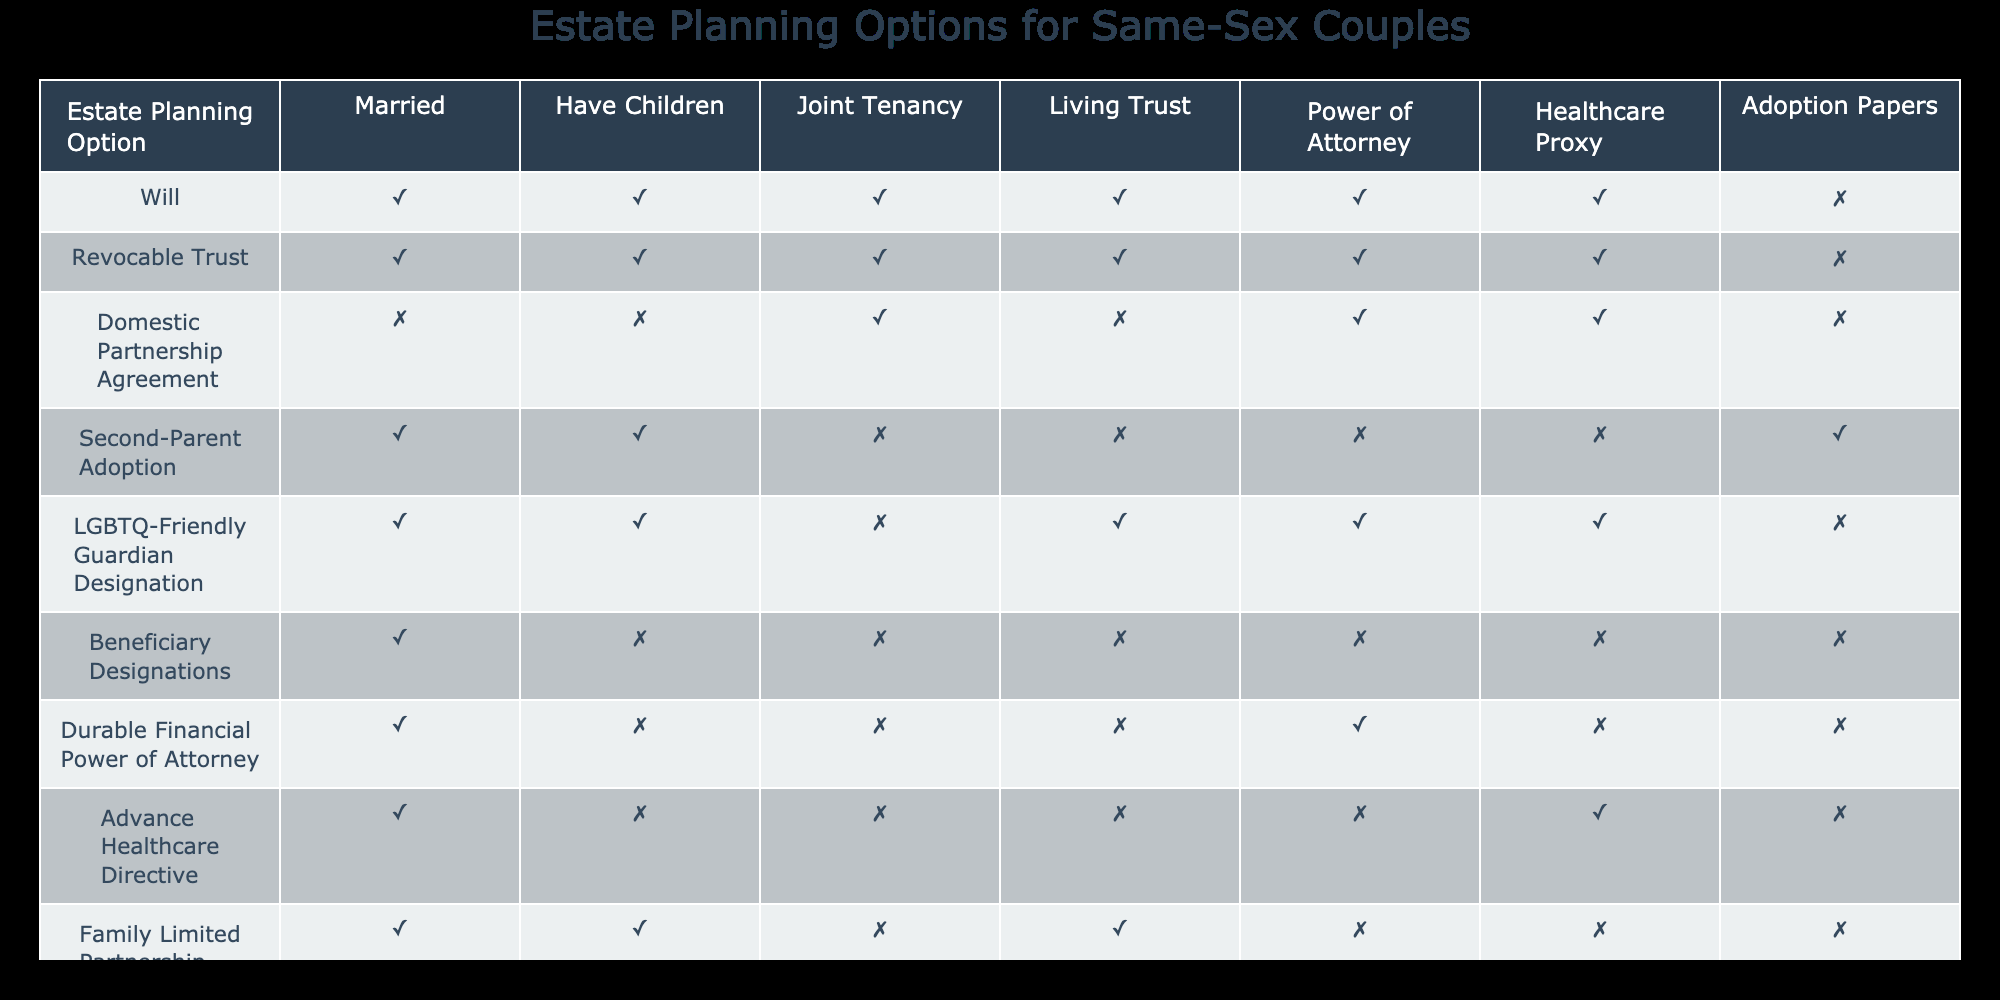What estate planning options are available for married same-sex couples with children? According to the table, married same-sex couples with children can use the following estate planning options: Will, Revocable Trust, Second-Parent Adoption, LGBTQ-Friendly Guardian Designation, Family Limited Partnership, and Qualified Terminable Interest Property Trust.
Answer: Will, Revocable Trust, Second-Parent Adoption, LGBTQ-Friendly Guardian Designation, Family Limited Partnership, Qualified Terminable Interest Property Trust Is a Domestic Partnership Agreement suitable for same-sex couples who have children? The table indicates that a Domestic Partnership Agreement is marked as applicable for couples without children (FALSE). Therefore, it is not suitable for same-sex couples who have children.
Answer: No How many estate planning options are available for same-sex couples without children? By looking at the table, the applicable options for same-sex couples without children are: Domestic Partnership Agreement, Beneficiary Designations, Durable Financial Power of Attorney, and Advance Healthcare Directive. This gives us a total of four options.
Answer: 4 Can same-sex couples benefit from Adoption Papers when they have children? The table shows that Adoption Papers are only applicable for same-sex couples who are married with children (TRUE). Thus, there is a benefit, but not for all couples with children.
Answer: Yes For LGBTQ-friendly Guardian Designation, is it available to married same-sex couples without children? The table specifies that LGBTQ-friendly Guardian Designation is applicable only to married couples with children (TRUE), meaning it is not available for those without children.
Answer: No Which two estate planning options are available for married couples with children but do not include Adoption Papers? Referring to the table, Married couples with children have several options excluding Adoption Papers: Will, Revocable Trust, LGBTQ-Friendly Guardian Designation, Family Limited Partnership, and Qualified Terminable Interest Property Trust. Choosing any two would fit this criterion, such as Will and Revocable Trust.
Answer: Will, Revocable Trust Which options require children for married same-sex couples? The table indicates that the following options require having children for married same-sex couples: Second-Parent Adoption and LGBTQ-Friendly Guardian Designation. Hence, the answer includes these two options.
Answer: Second-Parent Adoption, LGBTQ-Friendly Guardian Designation How many estate planning options exist for married same-sex couples that do not include healthcare-related documents? The options available for married same-sex couples that do not include healthcare-related documents are: Will, Revocable Trust, Joint Tenancy, Beneficiary Designations, and Family Limited Partnership. This totals five options.
Answer: 5 What are the differences between the estate planning options for same-sex couples who are married versus those in domestic partnerships? The table indicates that married couples have a wider range of estate planning options (seven) which include options like Revocable Trust and Second-Parent Adoption, while couples in domestic partnerships only have two applicable options: Domestic Partnership Agreement and Durable Financial Power of Attorney.
Answer: Married couples have more options 